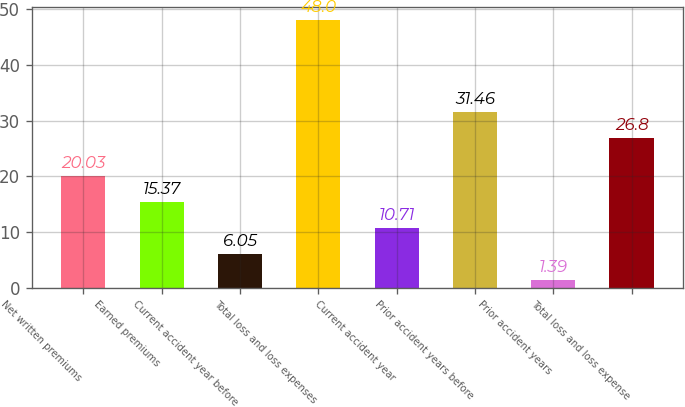Convert chart to OTSL. <chart><loc_0><loc_0><loc_500><loc_500><bar_chart><fcel>Net written premiums<fcel>Earned premiums<fcel>Current accident year before<fcel>Total loss and loss expenses<fcel>Current accident year<fcel>Prior accident years before<fcel>Prior accident years<fcel>Total loss and loss expense<nl><fcel>20.03<fcel>15.37<fcel>6.05<fcel>48<fcel>10.71<fcel>31.46<fcel>1.39<fcel>26.8<nl></chart> 